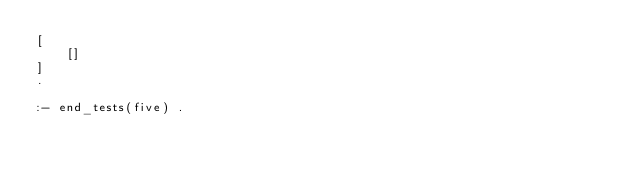<code> <loc_0><loc_0><loc_500><loc_500><_Prolog_>[
	[]
]
.

:- end_tests(five) .

</code> 